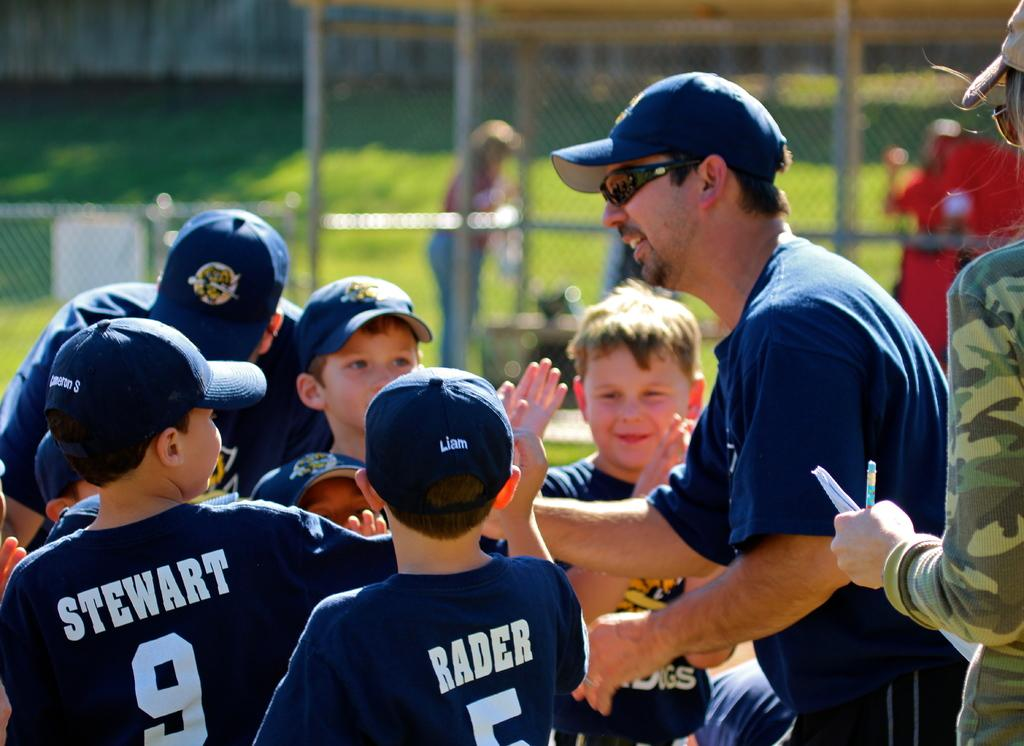<image>
Offer a succinct explanation of the picture presented. The coach is congratulating the team, including Stewart and Rader. 